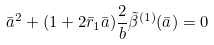Convert formula to latex. <formula><loc_0><loc_0><loc_500><loc_500>\bar { a } ^ { 2 } + ( 1 + 2 \bar { r } _ { 1 } \bar { a } ) \frac { 2 } { b } \tilde { \beta } ^ { ( 1 ) } ( \bar { a } ) = 0</formula> 